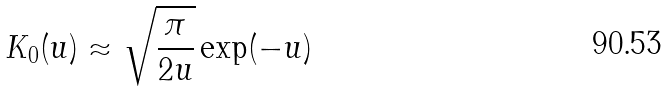<formula> <loc_0><loc_0><loc_500><loc_500>K _ { 0 } ( u ) \approx \sqrt { \frac { \pi } { 2 u } } \exp ( - u )</formula> 